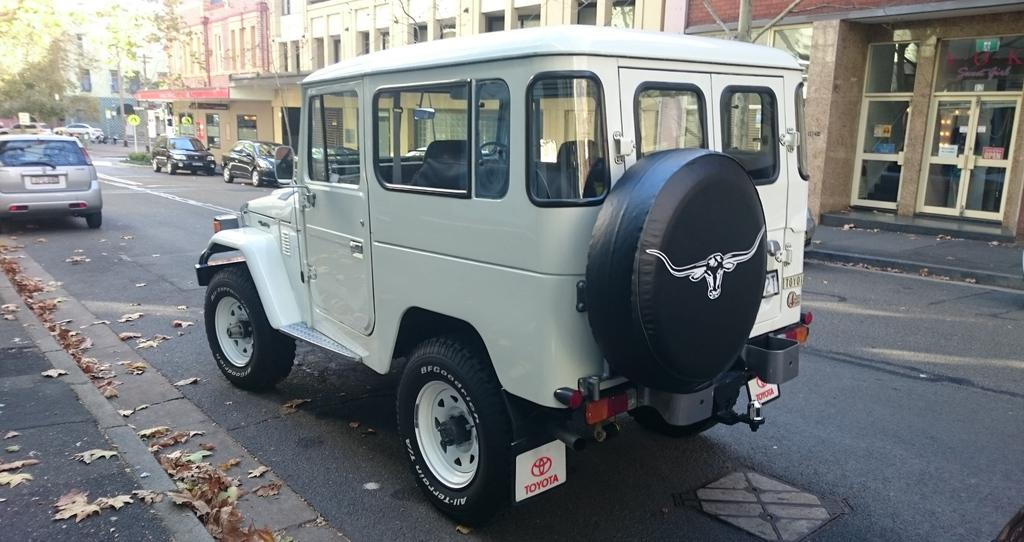What is happening on the road in the image? There are vehicles on the road in the image. What can be seen in the distance behind the vehicles? There are buildings, glass, sign boards, poles, trees, and plants in the background of the image. Can you describe the type of structures visible in the background? The buildings are visible in the background of the image. What might be used to display information or advertisements in the image? Sign boards are visible in the background of the image. What type of cable can be seen connecting the vehicles in the image? There is no cable connecting the vehicles in the image; they are separate entities on the road. 